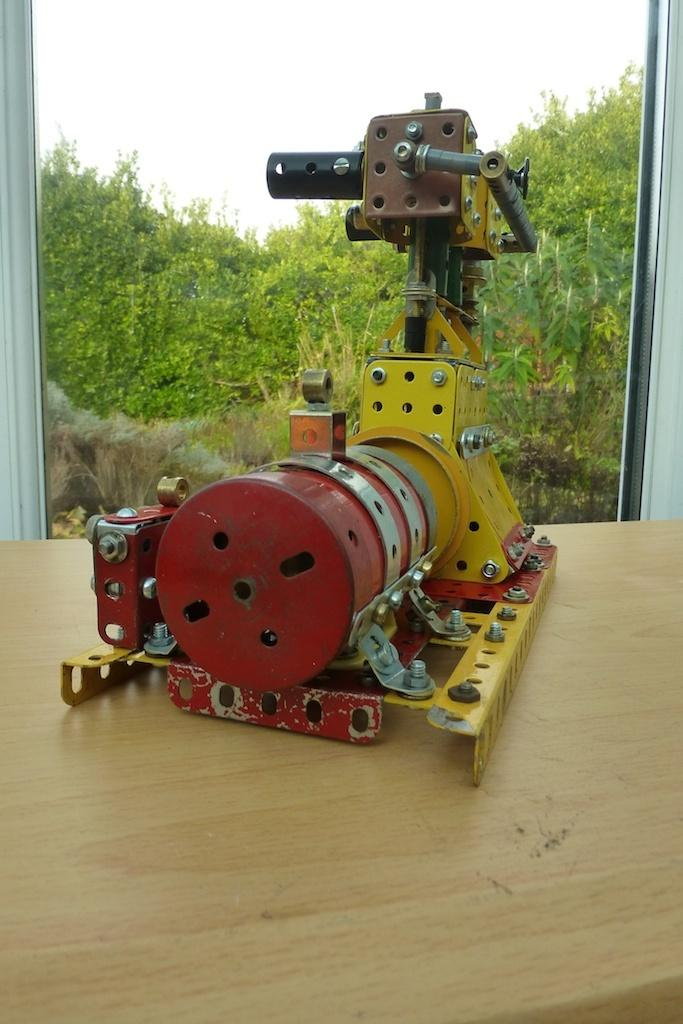What is the main object in the foreground of the image? There is a machine on a table in the foreground of the image. What can be seen in the background of the image? There is a window and trees visible in the background of the image. How many sidewalks are visible in the image? There are no sidewalks present in the image. What type of measuring device is used to store data in the image? There is no measuring device or data storage device present in the image. 